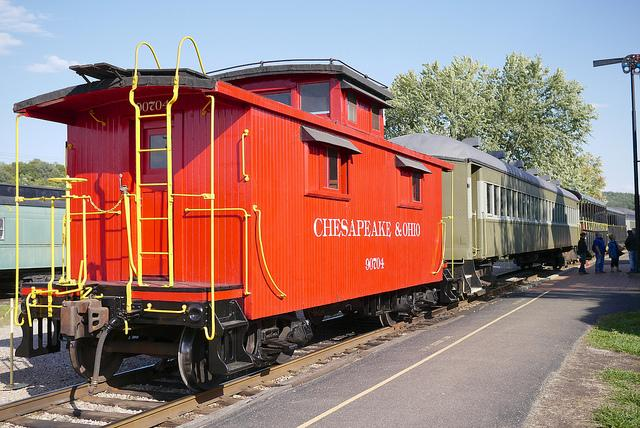The Chesapeake and Ohio Railway was a Class I railroad formed when?

Choices:
A) 1888
B) 1958
C) 1869
D) 1858 1869 